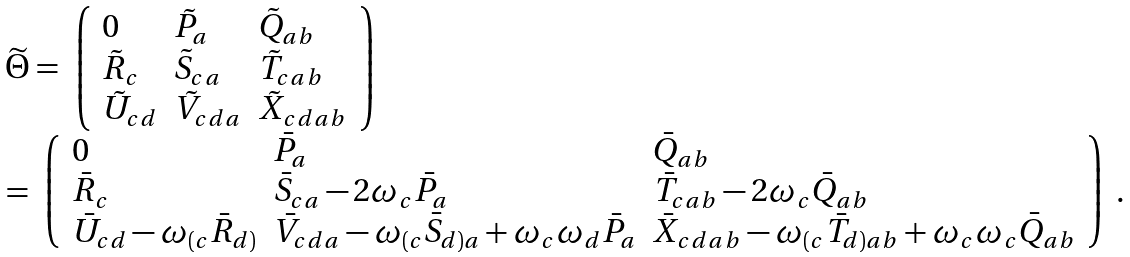<formula> <loc_0><loc_0><loc_500><loc_500>\begin{array} l \widetilde { \Theta } = \left \lgroup \begin{array} { l l l } 0 & \tilde { P } _ { a } & \tilde { Q } _ { a b } \\ \tilde { R } _ { c } & \tilde { S } _ { c a } & \tilde { T } _ { c a b } \\ \tilde { U } _ { c d } & \tilde { V } _ { c d a } & \tilde { X } _ { c d a b } \end{array} \right \rgroup \\ = \left \lgroup \begin{array} { l l l } 0 & \bar { P } _ { a } & \bar { Q } _ { a b } \\ \bar { R } _ { c } & \bar { S } _ { c a } - 2 \omega _ { c } \bar { P } _ { a } & \bar { T } _ { c a b } - 2 \omega _ { c } \bar { Q } _ { a b } \\ \bar { U } _ { c d } - \omega _ { ( c } \bar { R } _ { d ) } & \bar { V } _ { c d a } - \omega _ { ( c } \bar { S } _ { d ) a } + \omega _ { c } \omega _ { d } \bar { P } _ { a } & \bar { X } _ { c d a b } - \omega _ { ( c } \bar { T } _ { d ) a b } + \omega _ { c } \omega _ { c } \bar { Q } _ { a b } \end{array} \right \rgroup . \end{array}</formula> 